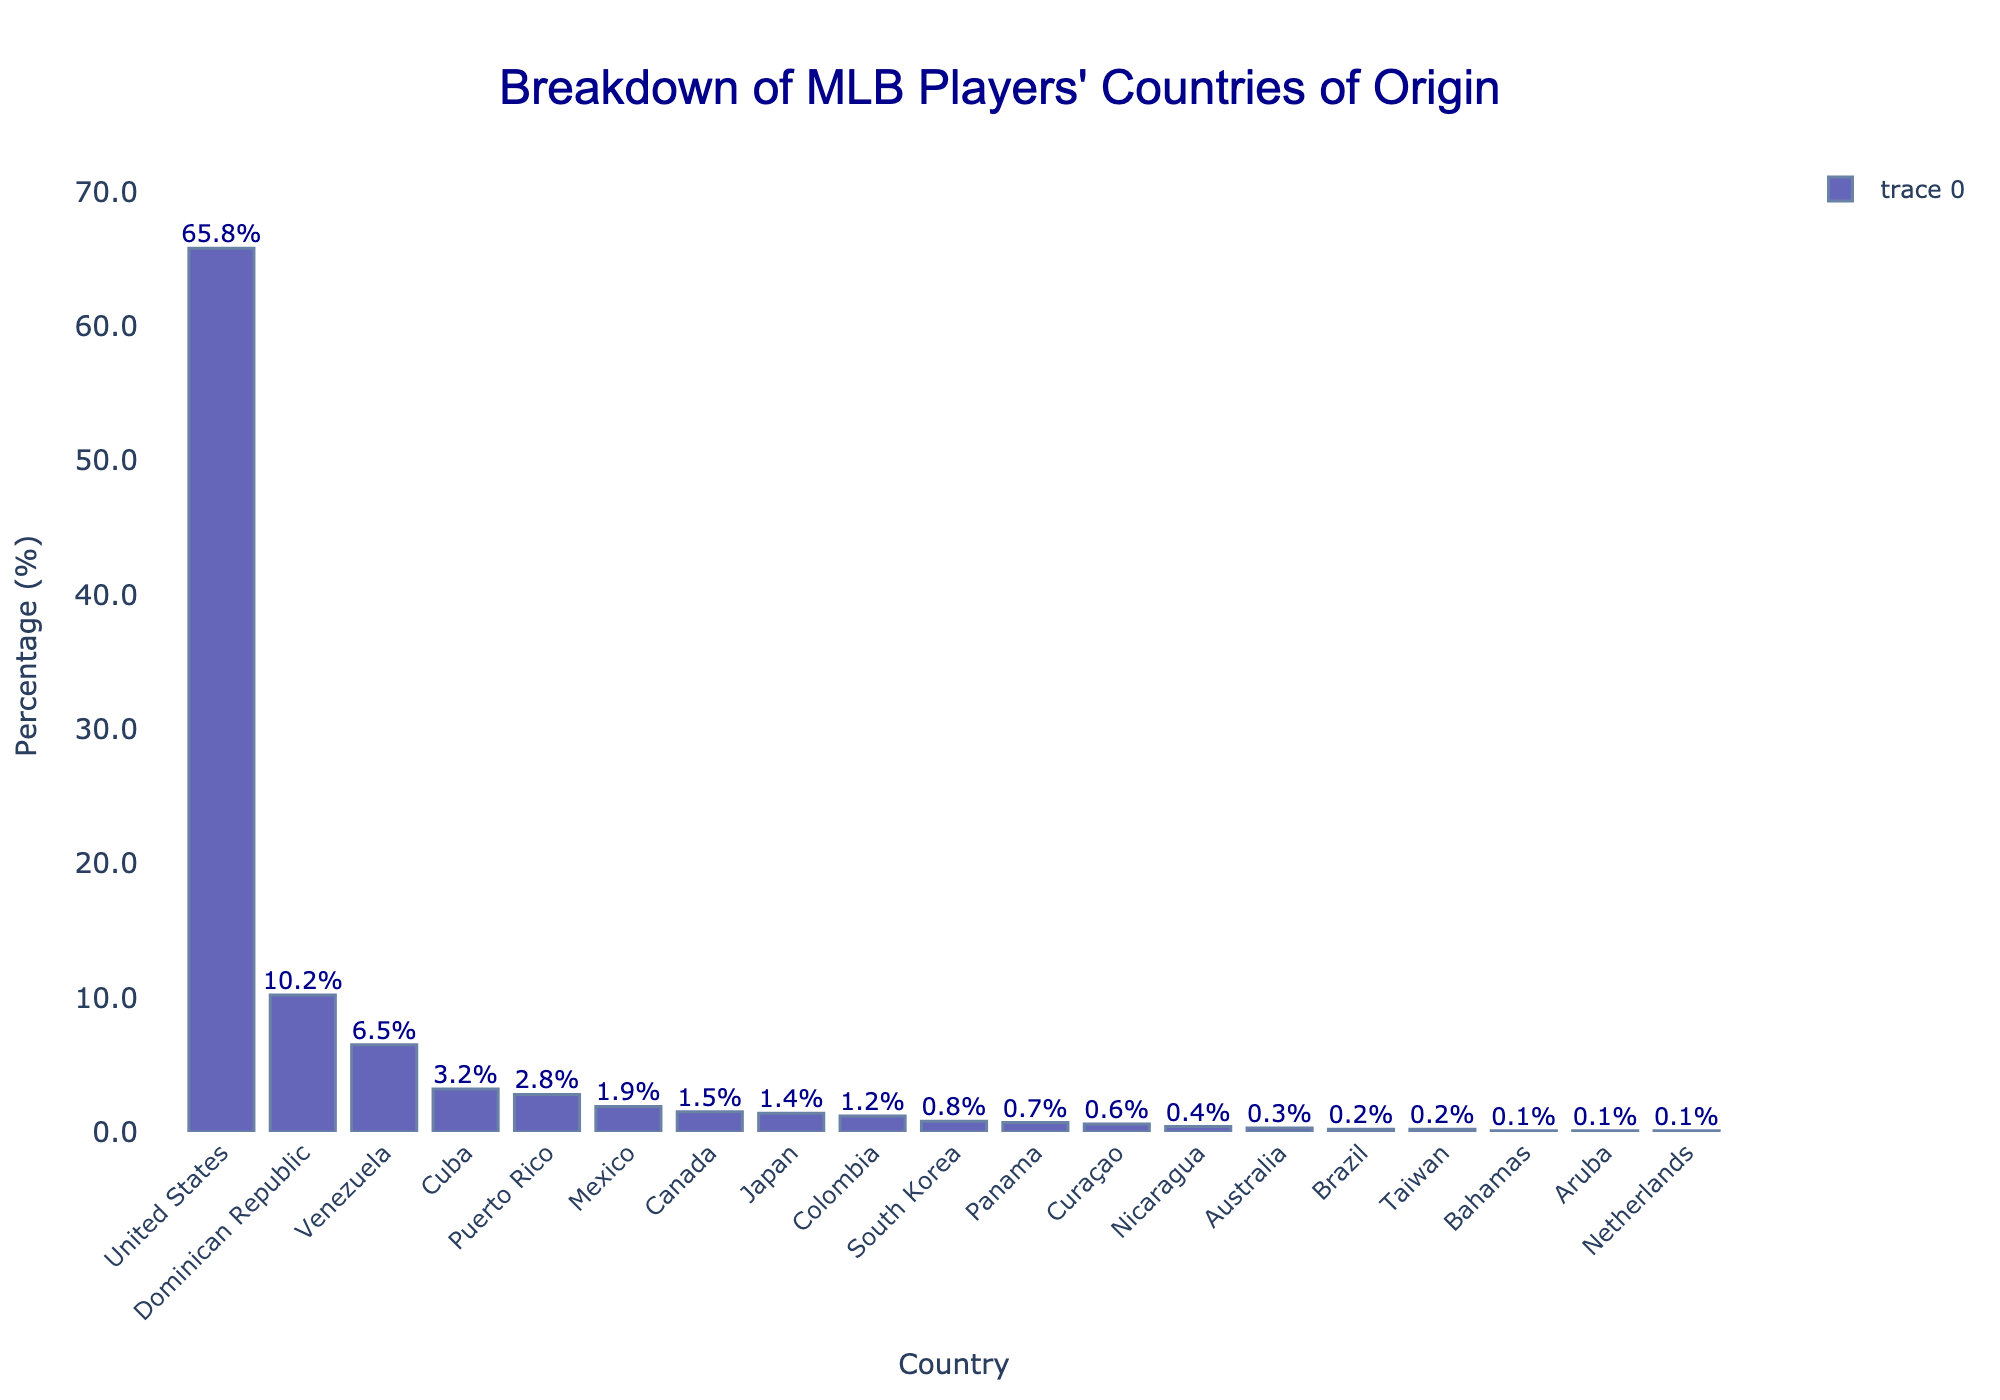Which country has the highest percentage of MLB players? The bar with the highest percentage represents the country with the most MLB players. The United States has the tallest bar.
Answer: United States Which country has the second-highest percentage of MLB players? The second tallest bar represents the country with the second-highest percentage of MLB players. The Dominican Republic has the second-highest bar.
Answer: Dominican Republic How many countries have a percentage of MLB players less than 1%? Count the number of bars that are below the 1% mark on the y-axis. These are: Canada, Japan, Colombia, South Korea, Panama, Curaçao, Nicaragua, Australia, Brazil, Taiwan, Bahamas, Aruba, and Netherlands.
Answer: 13 What is the difference in the percentage of MLB players between the United States and the Dominican Republic? Subtract the percentage of the Dominican Republic from the United States: 65.8% - 10.2% = 55.6%.
Answer: 55.6% Which Latin American country has the highest percentage of MLB players? Look for the Latin American countries and identify the one with the highest bar. The Dominican Republic has the highest percentage.
Answer: Dominican Republic How many countries have at least 2% of MLB players? Count the number of bars that are at or above the 2% mark on the y-axis. These are: United States, Dominican Republic, Venezuela, Cuba, and Puerto Rico.
Answer: 5 What is the total percentage of MLB players from Venezuela, Cuba, and Puerto Rico? Add the percentages of Venezuela, Cuba, and Puerto Rico: 6.5% + 3.2% + 2.8% = 12.5%.
Answer: 12.5% Which country has the lowest percentage of MLB players? Identify the shortest bar on the chart, which represents the country with the lowest percentage of MLB players. There are three countries tied at 0.1%: Aruba, Bahamas, and Netherlands.
Answer: Aruba, Bahamas, Netherlands Is the percentage of MLB players from Canada higher or lower than that from Japan? Compare the height of the bars for Canada and Japan. Canada's bar is slightly higher than Japan's.
Answer: Higher What is the approximate combined percentage of MLB players from Asian countries? Add the percentages of Japan, South Korea, and Taiwan: 1.4% + 0.8% + 0.2% = 2.4%.
Answer: 2.4% 